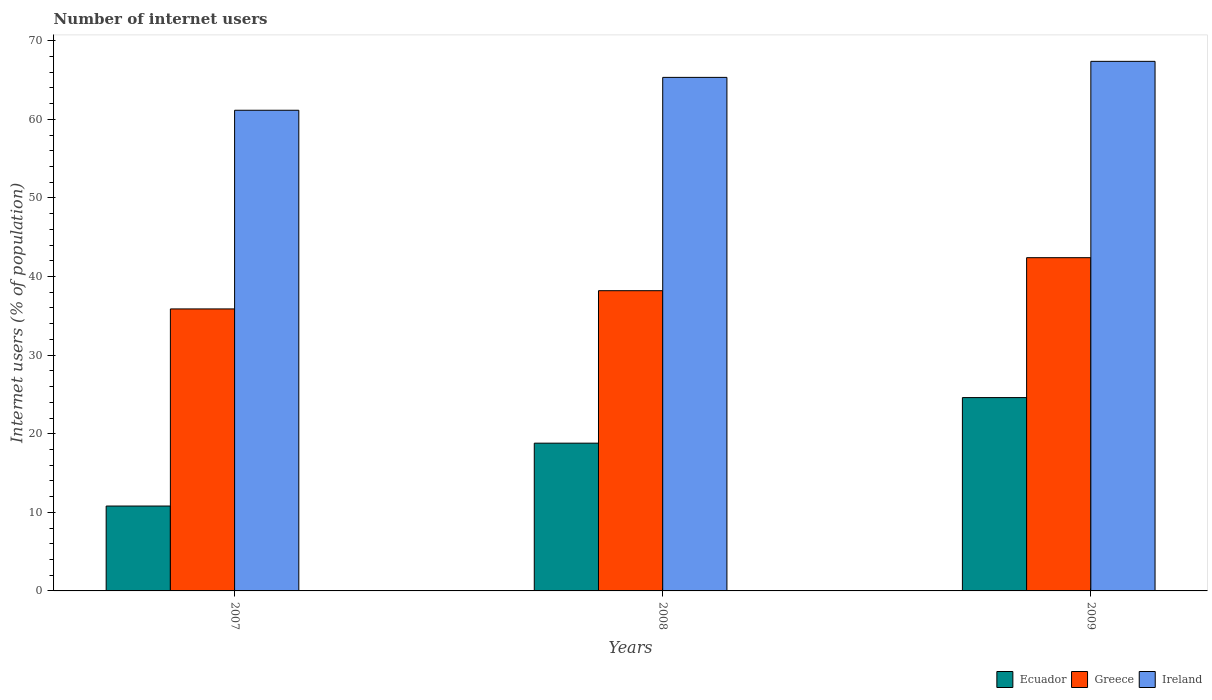Are the number of bars per tick equal to the number of legend labels?
Your answer should be very brief. Yes. Are the number of bars on each tick of the X-axis equal?
Make the answer very short. Yes. How many bars are there on the 3rd tick from the right?
Provide a short and direct response. 3. What is the label of the 1st group of bars from the left?
Keep it short and to the point. 2007. In how many cases, is the number of bars for a given year not equal to the number of legend labels?
Make the answer very short. 0. What is the number of internet users in Ecuador in 2009?
Ensure brevity in your answer.  24.6. Across all years, what is the maximum number of internet users in Ecuador?
Offer a terse response. 24.6. Across all years, what is the minimum number of internet users in Ecuador?
Provide a short and direct response. 10.8. In which year was the number of internet users in Greece maximum?
Offer a very short reply. 2009. In which year was the number of internet users in Ecuador minimum?
Your answer should be compact. 2007. What is the total number of internet users in Ecuador in the graph?
Provide a succinct answer. 54.2. What is the difference between the number of internet users in Greece in 2008 and the number of internet users in Ecuador in 2009?
Provide a succinct answer. 13.6. What is the average number of internet users in Ireland per year?
Your answer should be very brief. 64.63. In the year 2008, what is the difference between the number of internet users in Ireland and number of internet users in Greece?
Your response must be concise. 27.14. What is the ratio of the number of internet users in Greece in 2007 to that in 2009?
Make the answer very short. 0.85. Is the difference between the number of internet users in Ireland in 2008 and 2009 greater than the difference between the number of internet users in Greece in 2008 and 2009?
Your answer should be very brief. Yes. What is the difference between the highest and the second highest number of internet users in Ireland?
Your response must be concise. 2.04. What is the difference between the highest and the lowest number of internet users in Greece?
Provide a succinct answer. 6.52. In how many years, is the number of internet users in Greece greater than the average number of internet users in Greece taken over all years?
Ensure brevity in your answer.  1. Is the sum of the number of internet users in Ireland in 2007 and 2009 greater than the maximum number of internet users in Ecuador across all years?
Provide a succinct answer. Yes. What does the 1st bar from the left in 2008 represents?
Your response must be concise. Ecuador. What does the 1st bar from the right in 2008 represents?
Make the answer very short. Ireland. How many bars are there?
Your answer should be compact. 9. How many years are there in the graph?
Your answer should be compact. 3. What is the difference between two consecutive major ticks on the Y-axis?
Your response must be concise. 10. Are the values on the major ticks of Y-axis written in scientific E-notation?
Give a very brief answer. No. Does the graph contain any zero values?
Provide a succinct answer. No. What is the title of the graph?
Your answer should be compact. Number of internet users. What is the label or title of the Y-axis?
Give a very brief answer. Internet users (% of population). What is the Internet users (% of population) in Greece in 2007?
Offer a very short reply. 35.88. What is the Internet users (% of population) in Ireland in 2007?
Keep it short and to the point. 61.16. What is the Internet users (% of population) in Greece in 2008?
Make the answer very short. 38.2. What is the Internet users (% of population) of Ireland in 2008?
Ensure brevity in your answer.  65.34. What is the Internet users (% of population) in Ecuador in 2009?
Your answer should be compact. 24.6. What is the Internet users (% of population) of Greece in 2009?
Your response must be concise. 42.4. What is the Internet users (% of population) of Ireland in 2009?
Ensure brevity in your answer.  67.38. Across all years, what is the maximum Internet users (% of population) of Ecuador?
Provide a succinct answer. 24.6. Across all years, what is the maximum Internet users (% of population) of Greece?
Provide a succinct answer. 42.4. Across all years, what is the maximum Internet users (% of population) in Ireland?
Provide a succinct answer. 67.38. Across all years, what is the minimum Internet users (% of population) of Ecuador?
Your answer should be compact. 10.8. Across all years, what is the minimum Internet users (% of population) in Greece?
Provide a short and direct response. 35.88. Across all years, what is the minimum Internet users (% of population) of Ireland?
Your answer should be very brief. 61.16. What is the total Internet users (% of population) in Ecuador in the graph?
Keep it short and to the point. 54.2. What is the total Internet users (% of population) of Greece in the graph?
Your answer should be very brief. 116.48. What is the total Internet users (% of population) in Ireland in the graph?
Offer a terse response. 193.88. What is the difference between the Internet users (% of population) in Ecuador in 2007 and that in 2008?
Provide a short and direct response. -8. What is the difference between the Internet users (% of population) of Greece in 2007 and that in 2008?
Offer a terse response. -2.32. What is the difference between the Internet users (% of population) in Ireland in 2007 and that in 2008?
Give a very brief answer. -4.18. What is the difference between the Internet users (% of population) in Ecuador in 2007 and that in 2009?
Give a very brief answer. -13.8. What is the difference between the Internet users (% of population) of Greece in 2007 and that in 2009?
Your answer should be compact. -6.52. What is the difference between the Internet users (% of population) of Ireland in 2007 and that in 2009?
Your answer should be very brief. -6.22. What is the difference between the Internet users (% of population) of Greece in 2008 and that in 2009?
Keep it short and to the point. -4.2. What is the difference between the Internet users (% of population) in Ireland in 2008 and that in 2009?
Give a very brief answer. -2.04. What is the difference between the Internet users (% of population) of Ecuador in 2007 and the Internet users (% of population) of Greece in 2008?
Provide a succinct answer. -27.4. What is the difference between the Internet users (% of population) in Ecuador in 2007 and the Internet users (% of population) in Ireland in 2008?
Ensure brevity in your answer.  -54.54. What is the difference between the Internet users (% of population) of Greece in 2007 and the Internet users (% of population) of Ireland in 2008?
Offer a terse response. -29.46. What is the difference between the Internet users (% of population) of Ecuador in 2007 and the Internet users (% of population) of Greece in 2009?
Your answer should be very brief. -31.6. What is the difference between the Internet users (% of population) in Ecuador in 2007 and the Internet users (% of population) in Ireland in 2009?
Provide a short and direct response. -56.58. What is the difference between the Internet users (% of population) in Greece in 2007 and the Internet users (% of population) in Ireland in 2009?
Give a very brief answer. -31.5. What is the difference between the Internet users (% of population) of Ecuador in 2008 and the Internet users (% of population) of Greece in 2009?
Give a very brief answer. -23.6. What is the difference between the Internet users (% of population) of Ecuador in 2008 and the Internet users (% of population) of Ireland in 2009?
Keep it short and to the point. -48.58. What is the difference between the Internet users (% of population) in Greece in 2008 and the Internet users (% of population) in Ireland in 2009?
Your answer should be very brief. -29.18. What is the average Internet users (% of population) in Ecuador per year?
Your response must be concise. 18.07. What is the average Internet users (% of population) of Greece per year?
Your response must be concise. 38.83. What is the average Internet users (% of population) of Ireland per year?
Provide a succinct answer. 64.63. In the year 2007, what is the difference between the Internet users (% of population) of Ecuador and Internet users (% of population) of Greece?
Give a very brief answer. -25.08. In the year 2007, what is the difference between the Internet users (% of population) in Ecuador and Internet users (% of population) in Ireland?
Give a very brief answer. -50.36. In the year 2007, what is the difference between the Internet users (% of population) in Greece and Internet users (% of population) in Ireland?
Make the answer very short. -25.28. In the year 2008, what is the difference between the Internet users (% of population) in Ecuador and Internet users (% of population) in Greece?
Your answer should be very brief. -19.4. In the year 2008, what is the difference between the Internet users (% of population) of Ecuador and Internet users (% of population) of Ireland?
Provide a short and direct response. -46.54. In the year 2008, what is the difference between the Internet users (% of population) of Greece and Internet users (% of population) of Ireland?
Ensure brevity in your answer.  -27.14. In the year 2009, what is the difference between the Internet users (% of population) in Ecuador and Internet users (% of population) in Greece?
Give a very brief answer. -17.8. In the year 2009, what is the difference between the Internet users (% of population) in Ecuador and Internet users (% of population) in Ireland?
Your response must be concise. -42.78. In the year 2009, what is the difference between the Internet users (% of population) in Greece and Internet users (% of population) in Ireland?
Make the answer very short. -24.98. What is the ratio of the Internet users (% of population) in Ecuador in 2007 to that in 2008?
Provide a short and direct response. 0.57. What is the ratio of the Internet users (% of population) of Greece in 2007 to that in 2008?
Give a very brief answer. 0.94. What is the ratio of the Internet users (% of population) in Ireland in 2007 to that in 2008?
Make the answer very short. 0.94. What is the ratio of the Internet users (% of population) in Ecuador in 2007 to that in 2009?
Make the answer very short. 0.44. What is the ratio of the Internet users (% of population) of Greece in 2007 to that in 2009?
Ensure brevity in your answer.  0.85. What is the ratio of the Internet users (% of population) in Ireland in 2007 to that in 2009?
Provide a succinct answer. 0.91. What is the ratio of the Internet users (% of population) in Ecuador in 2008 to that in 2009?
Provide a succinct answer. 0.76. What is the ratio of the Internet users (% of population) of Greece in 2008 to that in 2009?
Your answer should be compact. 0.9. What is the ratio of the Internet users (% of population) of Ireland in 2008 to that in 2009?
Give a very brief answer. 0.97. What is the difference between the highest and the second highest Internet users (% of population) in Ecuador?
Provide a succinct answer. 5.8. What is the difference between the highest and the second highest Internet users (% of population) in Ireland?
Give a very brief answer. 2.04. What is the difference between the highest and the lowest Internet users (% of population) in Greece?
Provide a succinct answer. 6.52. What is the difference between the highest and the lowest Internet users (% of population) in Ireland?
Offer a terse response. 6.22. 